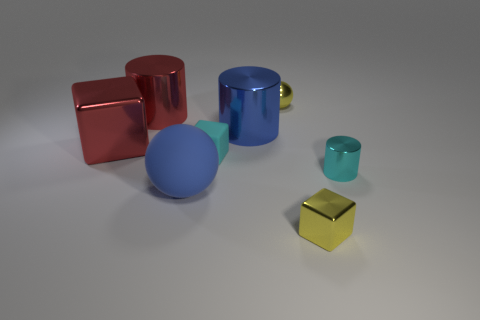What is the color of the metallic block that is to the left of the cyan block?
Provide a succinct answer. Red. The small rubber thing is what shape?
Provide a short and direct response. Cube. The cyan object that is to the right of the yellow object that is in front of the rubber ball is made of what material?
Keep it short and to the point. Metal. What number of other things are the same material as the yellow sphere?
Offer a very short reply. 5. What is the material of the blue object that is the same size as the blue sphere?
Your response must be concise. Metal. Are there more tiny yellow things behind the yellow metal block than large red metallic blocks that are on the right side of the blue sphere?
Keep it short and to the point. Yes. Is there a big purple metal thing that has the same shape as the small rubber thing?
Your answer should be very brief. No. There is a cyan thing that is the same size as the cyan shiny cylinder; what is its shape?
Your response must be concise. Cube. The small yellow thing right of the yellow shiny ball has what shape?
Your response must be concise. Cube. Is the number of large red objects behind the red cube less than the number of tiny cyan rubber cubes behind the tiny cyan rubber thing?
Offer a terse response. No. 